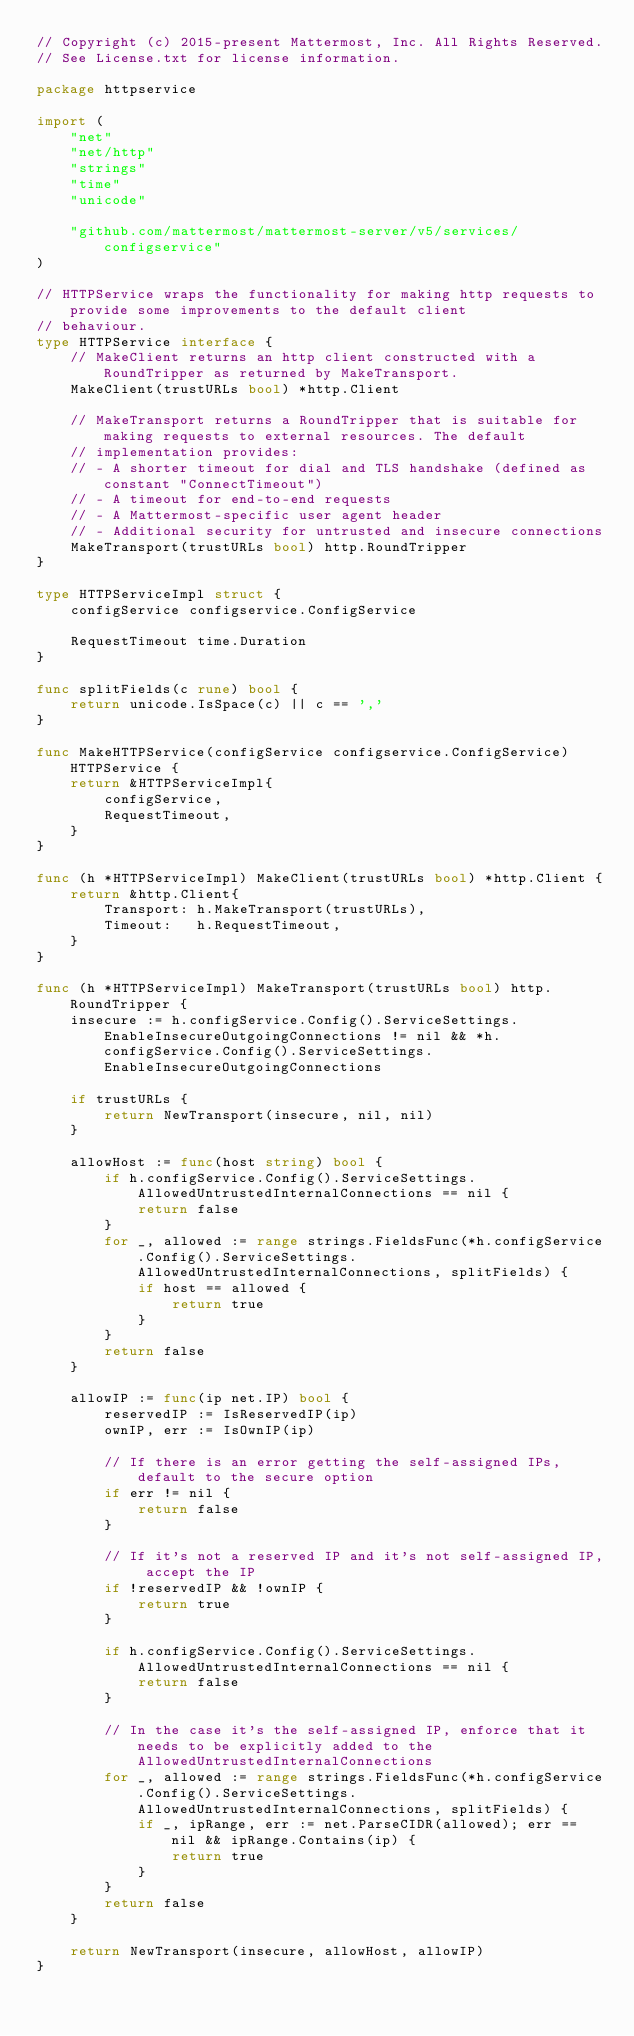Convert code to text. <code><loc_0><loc_0><loc_500><loc_500><_Go_>// Copyright (c) 2015-present Mattermost, Inc. All Rights Reserved.
// See License.txt for license information.

package httpservice

import (
	"net"
	"net/http"
	"strings"
	"time"
	"unicode"

	"github.com/mattermost/mattermost-server/v5/services/configservice"
)

// HTTPService wraps the functionality for making http requests to provide some improvements to the default client
// behaviour.
type HTTPService interface {
	// MakeClient returns an http client constructed with a RoundTripper as returned by MakeTransport.
	MakeClient(trustURLs bool) *http.Client

	// MakeTransport returns a RoundTripper that is suitable for making requests to external resources. The default
	// implementation provides:
	// - A shorter timeout for dial and TLS handshake (defined as constant "ConnectTimeout")
	// - A timeout for end-to-end requests
	// - A Mattermost-specific user agent header
	// - Additional security for untrusted and insecure connections
	MakeTransport(trustURLs bool) http.RoundTripper
}

type HTTPServiceImpl struct {
	configService configservice.ConfigService

	RequestTimeout time.Duration
}

func splitFields(c rune) bool {
	return unicode.IsSpace(c) || c == ','
}

func MakeHTTPService(configService configservice.ConfigService) HTTPService {
	return &HTTPServiceImpl{
		configService,
		RequestTimeout,
	}
}

func (h *HTTPServiceImpl) MakeClient(trustURLs bool) *http.Client {
	return &http.Client{
		Transport: h.MakeTransport(trustURLs),
		Timeout:   h.RequestTimeout,
	}
}

func (h *HTTPServiceImpl) MakeTransport(trustURLs bool) http.RoundTripper {
	insecure := h.configService.Config().ServiceSettings.EnableInsecureOutgoingConnections != nil && *h.configService.Config().ServiceSettings.EnableInsecureOutgoingConnections

	if trustURLs {
		return NewTransport(insecure, nil, nil)
	}

	allowHost := func(host string) bool {
		if h.configService.Config().ServiceSettings.AllowedUntrustedInternalConnections == nil {
			return false
		}
		for _, allowed := range strings.FieldsFunc(*h.configService.Config().ServiceSettings.AllowedUntrustedInternalConnections, splitFields) {
			if host == allowed {
				return true
			}
		}
		return false
	}

	allowIP := func(ip net.IP) bool {
		reservedIP := IsReservedIP(ip)
		ownIP, err := IsOwnIP(ip)

		// If there is an error getting the self-assigned IPs, default to the secure option
		if err != nil {
			return false
		}

		// If it's not a reserved IP and it's not self-assigned IP, accept the IP
		if !reservedIP && !ownIP {
			return true
		}

		if h.configService.Config().ServiceSettings.AllowedUntrustedInternalConnections == nil {
			return false
		}

		// In the case it's the self-assigned IP, enforce that it needs to be explicitly added to the AllowedUntrustedInternalConnections
		for _, allowed := range strings.FieldsFunc(*h.configService.Config().ServiceSettings.AllowedUntrustedInternalConnections, splitFields) {
			if _, ipRange, err := net.ParseCIDR(allowed); err == nil && ipRange.Contains(ip) {
				return true
			}
		}
		return false
	}

	return NewTransport(insecure, allowHost, allowIP)
}
</code> 